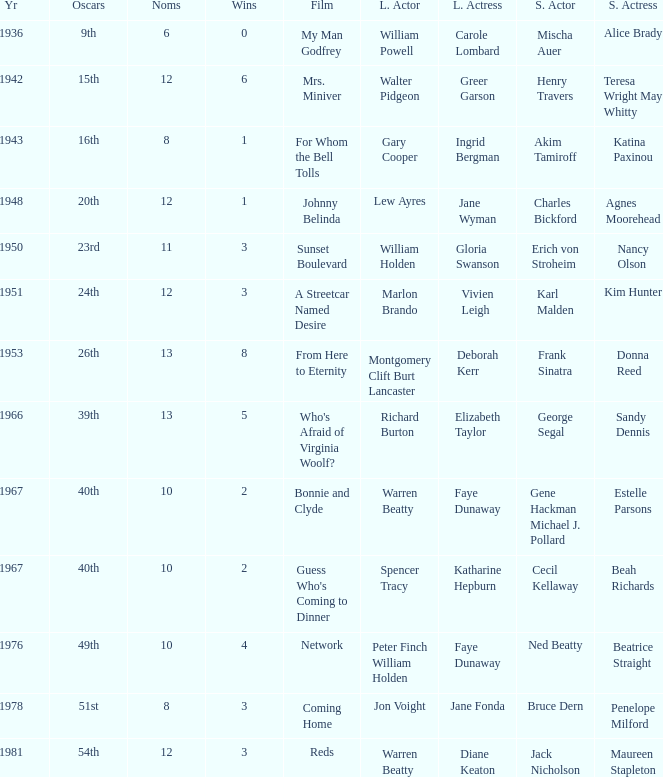Who was the leading actor in the film with a supporting actor named Cecil Kellaway? Spencer Tracy. 